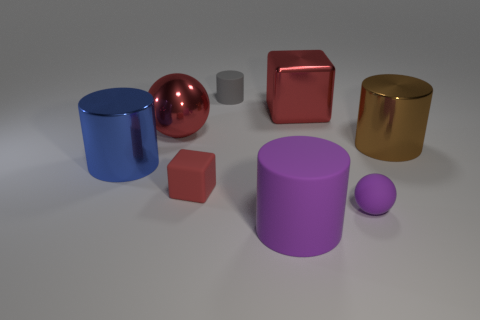Which object in the image is the largest, and what does its size suggest about its weight? The largest object appears to be the big brown cylinder on the left side of the image. If these were real objects, its size could suggest that it might be the heaviest among them, assuming all objects are made of materials with similar density. Assuming the objects are solid and made of the same material, what could be the purpose of arranging them like this? If we assume these are solid objects of the same material, this arrangement could serve an educational purpose, like a demonstration in a physics class about geometry, volume, and spatial awareness. It could also be part of a visual composition exercise in an art class, focusing on color contrast and the interplay of light on different surfaces. 